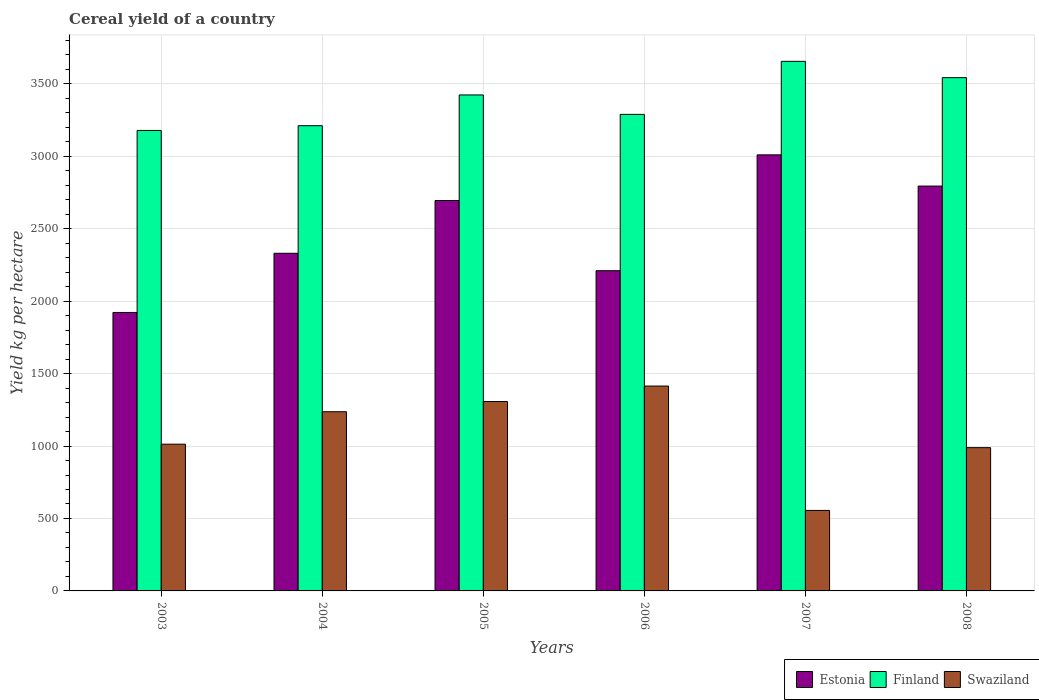Are the number of bars per tick equal to the number of legend labels?
Make the answer very short. Yes. How many bars are there on the 3rd tick from the left?
Make the answer very short. 3. What is the total cereal yield in Estonia in 2008?
Ensure brevity in your answer.  2794.05. Across all years, what is the maximum total cereal yield in Estonia?
Make the answer very short. 3009.47. Across all years, what is the minimum total cereal yield in Finland?
Keep it short and to the point. 3177.97. In which year was the total cereal yield in Swaziland minimum?
Provide a short and direct response. 2007. What is the total total cereal yield in Finland in the graph?
Provide a short and direct response. 2.03e+04. What is the difference between the total cereal yield in Swaziland in 2005 and that in 2007?
Your response must be concise. 751.38. What is the difference between the total cereal yield in Swaziland in 2008 and the total cereal yield in Finland in 2007?
Give a very brief answer. -2665.94. What is the average total cereal yield in Finland per year?
Provide a short and direct response. 3382.86. In the year 2007, what is the difference between the total cereal yield in Estonia and total cereal yield in Swaziland?
Keep it short and to the point. 2453.89. What is the ratio of the total cereal yield in Estonia in 2003 to that in 2005?
Provide a succinct answer. 0.71. What is the difference between the highest and the second highest total cereal yield in Estonia?
Keep it short and to the point. 215.42. What is the difference between the highest and the lowest total cereal yield in Finland?
Keep it short and to the point. 476.74. What does the 3rd bar from the left in 2008 represents?
Offer a terse response. Swaziland. What does the 1st bar from the right in 2005 represents?
Offer a very short reply. Swaziland. How many bars are there?
Ensure brevity in your answer.  18. Are all the bars in the graph horizontal?
Offer a terse response. No. How many years are there in the graph?
Your answer should be very brief. 6. What is the difference between two consecutive major ticks on the Y-axis?
Keep it short and to the point. 500. Are the values on the major ticks of Y-axis written in scientific E-notation?
Provide a succinct answer. No. Does the graph contain grids?
Offer a terse response. Yes. What is the title of the graph?
Provide a short and direct response. Cereal yield of a country. What is the label or title of the X-axis?
Keep it short and to the point. Years. What is the label or title of the Y-axis?
Make the answer very short. Yield kg per hectare. What is the Yield kg per hectare of Estonia in 2003?
Offer a terse response. 1921.7. What is the Yield kg per hectare of Finland in 2003?
Provide a succinct answer. 3177.97. What is the Yield kg per hectare of Swaziland in 2003?
Provide a short and direct response. 1012.66. What is the Yield kg per hectare of Estonia in 2004?
Offer a terse response. 2330.26. What is the Yield kg per hectare in Finland in 2004?
Make the answer very short. 3210.63. What is the Yield kg per hectare in Swaziland in 2004?
Offer a very short reply. 1236.66. What is the Yield kg per hectare in Estonia in 2005?
Provide a succinct answer. 2694.4. What is the Yield kg per hectare of Finland in 2005?
Give a very brief answer. 3422.92. What is the Yield kg per hectare in Swaziland in 2005?
Provide a succinct answer. 1306.95. What is the Yield kg per hectare in Estonia in 2006?
Make the answer very short. 2209.9. What is the Yield kg per hectare of Finland in 2006?
Provide a short and direct response. 3288.7. What is the Yield kg per hectare in Swaziland in 2006?
Your response must be concise. 1413.9. What is the Yield kg per hectare in Estonia in 2007?
Your response must be concise. 3009.47. What is the Yield kg per hectare in Finland in 2007?
Give a very brief answer. 3654.71. What is the Yield kg per hectare of Swaziland in 2007?
Your response must be concise. 555.57. What is the Yield kg per hectare of Estonia in 2008?
Your response must be concise. 2794.05. What is the Yield kg per hectare of Finland in 2008?
Your response must be concise. 3542.26. What is the Yield kg per hectare in Swaziland in 2008?
Offer a terse response. 988.77. Across all years, what is the maximum Yield kg per hectare of Estonia?
Provide a succinct answer. 3009.47. Across all years, what is the maximum Yield kg per hectare in Finland?
Keep it short and to the point. 3654.71. Across all years, what is the maximum Yield kg per hectare of Swaziland?
Offer a very short reply. 1413.9. Across all years, what is the minimum Yield kg per hectare in Estonia?
Provide a short and direct response. 1921.7. Across all years, what is the minimum Yield kg per hectare of Finland?
Offer a very short reply. 3177.97. Across all years, what is the minimum Yield kg per hectare in Swaziland?
Make the answer very short. 555.57. What is the total Yield kg per hectare in Estonia in the graph?
Give a very brief answer. 1.50e+04. What is the total Yield kg per hectare in Finland in the graph?
Your answer should be compact. 2.03e+04. What is the total Yield kg per hectare in Swaziland in the graph?
Provide a succinct answer. 6514.52. What is the difference between the Yield kg per hectare in Estonia in 2003 and that in 2004?
Offer a terse response. -408.56. What is the difference between the Yield kg per hectare of Finland in 2003 and that in 2004?
Ensure brevity in your answer.  -32.66. What is the difference between the Yield kg per hectare in Swaziland in 2003 and that in 2004?
Provide a short and direct response. -224. What is the difference between the Yield kg per hectare of Estonia in 2003 and that in 2005?
Your answer should be compact. -772.7. What is the difference between the Yield kg per hectare of Finland in 2003 and that in 2005?
Provide a short and direct response. -244.95. What is the difference between the Yield kg per hectare of Swaziland in 2003 and that in 2005?
Provide a short and direct response. -294.29. What is the difference between the Yield kg per hectare in Estonia in 2003 and that in 2006?
Provide a short and direct response. -288.2. What is the difference between the Yield kg per hectare of Finland in 2003 and that in 2006?
Offer a very short reply. -110.73. What is the difference between the Yield kg per hectare of Swaziland in 2003 and that in 2006?
Provide a short and direct response. -401.24. What is the difference between the Yield kg per hectare in Estonia in 2003 and that in 2007?
Make the answer very short. -1087.77. What is the difference between the Yield kg per hectare in Finland in 2003 and that in 2007?
Keep it short and to the point. -476.74. What is the difference between the Yield kg per hectare of Swaziland in 2003 and that in 2007?
Give a very brief answer. 457.09. What is the difference between the Yield kg per hectare in Estonia in 2003 and that in 2008?
Ensure brevity in your answer.  -872.35. What is the difference between the Yield kg per hectare of Finland in 2003 and that in 2008?
Provide a succinct answer. -364.29. What is the difference between the Yield kg per hectare in Swaziland in 2003 and that in 2008?
Provide a succinct answer. 23.89. What is the difference between the Yield kg per hectare in Estonia in 2004 and that in 2005?
Your answer should be compact. -364.14. What is the difference between the Yield kg per hectare of Finland in 2004 and that in 2005?
Make the answer very short. -212.29. What is the difference between the Yield kg per hectare in Swaziland in 2004 and that in 2005?
Your answer should be very brief. -70.29. What is the difference between the Yield kg per hectare of Estonia in 2004 and that in 2006?
Your answer should be very brief. 120.35. What is the difference between the Yield kg per hectare of Finland in 2004 and that in 2006?
Your answer should be very brief. -78.07. What is the difference between the Yield kg per hectare of Swaziland in 2004 and that in 2006?
Offer a terse response. -177.24. What is the difference between the Yield kg per hectare in Estonia in 2004 and that in 2007?
Offer a terse response. -679.21. What is the difference between the Yield kg per hectare in Finland in 2004 and that in 2007?
Ensure brevity in your answer.  -444.08. What is the difference between the Yield kg per hectare in Swaziland in 2004 and that in 2007?
Your answer should be compact. 681.09. What is the difference between the Yield kg per hectare of Estonia in 2004 and that in 2008?
Ensure brevity in your answer.  -463.8. What is the difference between the Yield kg per hectare in Finland in 2004 and that in 2008?
Provide a short and direct response. -331.63. What is the difference between the Yield kg per hectare of Swaziland in 2004 and that in 2008?
Provide a short and direct response. 247.89. What is the difference between the Yield kg per hectare of Estonia in 2005 and that in 2006?
Your response must be concise. 484.49. What is the difference between the Yield kg per hectare of Finland in 2005 and that in 2006?
Your response must be concise. 134.22. What is the difference between the Yield kg per hectare in Swaziland in 2005 and that in 2006?
Provide a short and direct response. -106.94. What is the difference between the Yield kg per hectare of Estonia in 2005 and that in 2007?
Ensure brevity in your answer.  -315.07. What is the difference between the Yield kg per hectare of Finland in 2005 and that in 2007?
Provide a succinct answer. -231.78. What is the difference between the Yield kg per hectare in Swaziland in 2005 and that in 2007?
Ensure brevity in your answer.  751.38. What is the difference between the Yield kg per hectare in Estonia in 2005 and that in 2008?
Offer a terse response. -99.66. What is the difference between the Yield kg per hectare in Finland in 2005 and that in 2008?
Keep it short and to the point. -119.33. What is the difference between the Yield kg per hectare of Swaziland in 2005 and that in 2008?
Offer a very short reply. 318.18. What is the difference between the Yield kg per hectare of Estonia in 2006 and that in 2007?
Offer a terse response. -799.57. What is the difference between the Yield kg per hectare of Finland in 2006 and that in 2007?
Provide a succinct answer. -366. What is the difference between the Yield kg per hectare of Swaziland in 2006 and that in 2007?
Your response must be concise. 858.33. What is the difference between the Yield kg per hectare of Estonia in 2006 and that in 2008?
Your answer should be very brief. -584.15. What is the difference between the Yield kg per hectare in Finland in 2006 and that in 2008?
Provide a short and direct response. -253.55. What is the difference between the Yield kg per hectare in Swaziland in 2006 and that in 2008?
Your answer should be compact. 425.13. What is the difference between the Yield kg per hectare in Estonia in 2007 and that in 2008?
Your answer should be compact. 215.42. What is the difference between the Yield kg per hectare in Finland in 2007 and that in 2008?
Ensure brevity in your answer.  112.45. What is the difference between the Yield kg per hectare of Swaziland in 2007 and that in 2008?
Provide a succinct answer. -433.2. What is the difference between the Yield kg per hectare in Estonia in 2003 and the Yield kg per hectare in Finland in 2004?
Ensure brevity in your answer.  -1288.93. What is the difference between the Yield kg per hectare of Estonia in 2003 and the Yield kg per hectare of Swaziland in 2004?
Your answer should be very brief. 685.04. What is the difference between the Yield kg per hectare of Finland in 2003 and the Yield kg per hectare of Swaziland in 2004?
Provide a succinct answer. 1941.31. What is the difference between the Yield kg per hectare of Estonia in 2003 and the Yield kg per hectare of Finland in 2005?
Provide a succinct answer. -1501.22. What is the difference between the Yield kg per hectare in Estonia in 2003 and the Yield kg per hectare in Swaziland in 2005?
Ensure brevity in your answer.  614.75. What is the difference between the Yield kg per hectare of Finland in 2003 and the Yield kg per hectare of Swaziland in 2005?
Ensure brevity in your answer.  1871.02. What is the difference between the Yield kg per hectare in Estonia in 2003 and the Yield kg per hectare in Finland in 2006?
Offer a terse response. -1367. What is the difference between the Yield kg per hectare of Estonia in 2003 and the Yield kg per hectare of Swaziland in 2006?
Your answer should be compact. 507.8. What is the difference between the Yield kg per hectare of Finland in 2003 and the Yield kg per hectare of Swaziland in 2006?
Your answer should be compact. 1764.07. What is the difference between the Yield kg per hectare in Estonia in 2003 and the Yield kg per hectare in Finland in 2007?
Give a very brief answer. -1733.01. What is the difference between the Yield kg per hectare in Estonia in 2003 and the Yield kg per hectare in Swaziland in 2007?
Offer a very short reply. 1366.13. What is the difference between the Yield kg per hectare in Finland in 2003 and the Yield kg per hectare in Swaziland in 2007?
Make the answer very short. 2622.4. What is the difference between the Yield kg per hectare of Estonia in 2003 and the Yield kg per hectare of Finland in 2008?
Keep it short and to the point. -1620.56. What is the difference between the Yield kg per hectare of Estonia in 2003 and the Yield kg per hectare of Swaziland in 2008?
Your answer should be compact. 932.93. What is the difference between the Yield kg per hectare in Finland in 2003 and the Yield kg per hectare in Swaziland in 2008?
Offer a very short reply. 2189.2. What is the difference between the Yield kg per hectare in Estonia in 2004 and the Yield kg per hectare in Finland in 2005?
Give a very brief answer. -1092.66. What is the difference between the Yield kg per hectare of Estonia in 2004 and the Yield kg per hectare of Swaziland in 2005?
Your response must be concise. 1023.3. What is the difference between the Yield kg per hectare in Finland in 2004 and the Yield kg per hectare in Swaziland in 2005?
Your answer should be very brief. 1903.67. What is the difference between the Yield kg per hectare in Estonia in 2004 and the Yield kg per hectare in Finland in 2006?
Your answer should be compact. -958.45. What is the difference between the Yield kg per hectare in Estonia in 2004 and the Yield kg per hectare in Swaziland in 2006?
Your answer should be compact. 916.36. What is the difference between the Yield kg per hectare of Finland in 2004 and the Yield kg per hectare of Swaziland in 2006?
Your answer should be compact. 1796.73. What is the difference between the Yield kg per hectare of Estonia in 2004 and the Yield kg per hectare of Finland in 2007?
Provide a succinct answer. -1324.45. What is the difference between the Yield kg per hectare in Estonia in 2004 and the Yield kg per hectare in Swaziland in 2007?
Your answer should be very brief. 1774.68. What is the difference between the Yield kg per hectare of Finland in 2004 and the Yield kg per hectare of Swaziland in 2007?
Give a very brief answer. 2655.05. What is the difference between the Yield kg per hectare of Estonia in 2004 and the Yield kg per hectare of Finland in 2008?
Give a very brief answer. -1212. What is the difference between the Yield kg per hectare in Estonia in 2004 and the Yield kg per hectare in Swaziland in 2008?
Offer a terse response. 1341.49. What is the difference between the Yield kg per hectare of Finland in 2004 and the Yield kg per hectare of Swaziland in 2008?
Provide a short and direct response. 2221.86. What is the difference between the Yield kg per hectare in Estonia in 2005 and the Yield kg per hectare in Finland in 2006?
Provide a succinct answer. -594.31. What is the difference between the Yield kg per hectare of Estonia in 2005 and the Yield kg per hectare of Swaziland in 2006?
Provide a succinct answer. 1280.5. What is the difference between the Yield kg per hectare in Finland in 2005 and the Yield kg per hectare in Swaziland in 2006?
Your answer should be very brief. 2009.02. What is the difference between the Yield kg per hectare in Estonia in 2005 and the Yield kg per hectare in Finland in 2007?
Your answer should be compact. -960.31. What is the difference between the Yield kg per hectare of Estonia in 2005 and the Yield kg per hectare of Swaziland in 2007?
Your answer should be very brief. 2138.82. What is the difference between the Yield kg per hectare of Finland in 2005 and the Yield kg per hectare of Swaziland in 2007?
Make the answer very short. 2867.35. What is the difference between the Yield kg per hectare of Estonia in 2005 and the Yield kg per hectare of Finland in 2008?
Provide a succinct answer. -847.86. What is the difference between the Yield kg per hectare of Estonia in 2005 and the Yield kg per hectare of Swaziland in 2008?
Offer a very short reply. 1705.63. What is the difference between the Yield kg per hectare in Finland in 2005 and the Yield kg per hectare in Swaziland in 2008?
Your answer should be very brief. 2434.15. What is the difference between the Yield kg per hectare of Estonia in 2006 and the Yield kg per hectare of Finland in 2007?
Offer a terse response. -1444.8. What is the difference between the Yield kg per hectare in Estonia in 2006 and the Yield kg per hectare in Swaziland in 2007?
Offer a terse response. 1654.33. What is the difference between the Yield kg per hectare of Finland in 2006 and the Yield kg per hectare of Swaziland in 2007?
Provide a succinct answer. 2733.13. What is the difference between the Yield kg per hectare in Estonia in 2006 and the Yield kg per hectare in Finland in 2008?
Offer a very short reply. -1332.35. What is the difference between the Yield kg per hectare in Estonia in 2006 and the Yield kg per hectare in Swaziland in 2008?
Provide a short and direct response. 1221.13. What is the difference between the Yield kg per hectare of Finland in 2006 and the Yield kg per hectare of Swaziland in 2008?
Ensure brevity in your answer.  2299.93. What is the difference between the Yield kg per hectare in Estonia in 2007 and the Yield kg per hectare in Finland in 2008?
Ensure brevity in your answer.  -532.79. What is the difference between the Yield kg per hectare in Estonia in 2007 and the Yield kg per hectare in Swaziland in 2008?
Your answer should be compact. 2020.7. What is the difference between the Yield kg per hectare of Finland in 2007 and the Yield kg per hectare of Swaziland in 2008?
Provide a succinct answer. 2665.94. What is the average Yield kg per hectare of Estonia per year?
Your answer should be compact. 2493.3. What is the average Yield kg per hectare in Finland per year?
Offer a terse response. 3382.86. What is the average Yield kg per hectare in Swaziland per year?
Your response must be concise. 1085.75. In the year 2003, what is the difference between the Yield kg per hectare of Estonia and Yield kg per hectare of Finland?
Ensure brevity in your answer.  -1256.27. In the year 2003, what is the difference between the Yield kg per hectare of Estonia and Yield kg per hectare of Swaziland?
Keep it short and to the point. 909.04. In the year 2003, what is the difference between the Yield kg per hectare in Finland and Yield kg per hectare in Swaziland?
Your answer should be compact. 2165.31. In the year 2004, what is the difference between the Yield kg per hectare in Estonia and Yield kg per hectare in Finland?
Make the answer very short. -880.37. In the year 2004, what is the difference between the Yield kg per hectare of Estonia and Yield kg per hectare of Swaziland?
Give a very brief answer. 1093.6. In the year 2004, what is the difference between the Yield kg per hectare in Finland and Yield kg per hectare in Swaziland?
Offer a terse response. 1973.97. In the year 2005, what is the difference between the Yield kg per hectare in Estonia and Yield kg per hectare in Finland?
Offer a very short reply. -728.52. In the year 2005, what is the difference between the Yield kg per hectare of Estonia and Yield kg per hectare of Swaziland?
Your answer should be very brief. 1387.44. In the year 2005, what is the difference between the Yield kg per hectare of Finland and Yield kg per hectare of Swaziland?
Your response must be concise. 2115.97. In the year 2006, what is the difference between the Yield kg per hectare of Estonia and Yield kg per hectare of Finland?
Make the answer very short. -1078.8. In the year 2006, what is the difference between the Yield kg per hectare in Estonia and Yield kg per hectare in Swaziland?
Provide a short and direct response. 796. In the year 2006, what is the difference between the Yield kg per hectare in Finland and Yield kg per hectare in Swaziland?
Your response must be concise. 1874.8. In the year 2007, what is the difference between the Yield kg per hectare in Estonia and Yield kg per hectare in Finland?
Keep it short and to the point. -645.24. In the year 2007, what is the difference between the Yield kg per hectare of Estonia and Yield kg per hectare of Swaziland?
Offer a very short reply. 2453.89. In the year 2007, what is the difference between the Yield kg per hectare in Finland and Yield kg per hectare in Swaziland?
Ensure brevity in your answer.  3099.13. In the year 2008, what is the difference between the Yield kg per hectare of Estonia and Yield kg per hectare of Finland?
Provide a succinct answer. -748.21. In the year 2008, what is the difference between the Yield kg per hectare of Estonia and Yield kg per hectare of Swaziland?
Keep it short and to the point. 1805.28. In the year 2008, what is the difference between the Yield kg per hectare of Finland and Yield kg per hectare of Swaziland?
Ensure brevity in your answer.  2553.49. What is the ratio of the Yield kg per hectare in Estonia in 2003 to that in 2004?
Your response must be concise. 0.82. What is the ratio of the Yield kg per hectare of Finland in 2003 to that in 2004?
Provide a succinct answer. 0.99. What is the ratio of the Yield kg per hectare of Swaziland in 2003 to that in 2004?
Your answer should be compact. 0.82. What is the ratio of the Yield kg per hectare in Estonia in 2003 to that in 2005?
Your answer should be compact. 0.71. What is the ratio of the Yield kg per hectare of Finland in 2003 to that in 2005?
Your answer should be very brief. 0.93. What is the ratio of the Yield kg per hectare of Swaziland in 2003 to that in 2005?
Ensure brevity in your answer.  0.77. What is the ratio of the Yield kg per hectare in Estonia in 2003 to that in 2006?
Offer a terse response. 0.87. What is the ratio of the Yield kg per hectare of Finland in 2003 to that in 2006?
Keep it short and to the point. 0.97. What is the ratio of the Yield kg per hectare in Swaziland in 2003 to that in 2006?
Offer a very short reply. 0.72. What is the ratio of the Yield kg per hectare of Estonia in 2003 to that in 2007?
Your answer should be compact. 0.64. What is the ratio of the Yield kg per hectare in Finland in 2003 to that in 2007?
Your answer should be compact. 0.87. What is the ratio of the Yield kg per hectare in Swaziland in 2003 to that in 2007?
Your answer should be compact. 1.82. What is the ratio of the Yield kg per hectare in Estonia in 2003 to that in 2008?
Provide a short and direct response. 0.69. What is the ratio of the Yield kg per hectare of Finland in 2003 to that in 2008?
Your answer should be very brief. 0.9. What is the ratio of the Yield kg per hectare in Swaziland in 2003 to that in 2008?
Keep it short and to the point. 1.02. What is the ratio of the Yield kg per hectare in Estonia in 2004 to that in 2005?
Keep it short and to the point. 0.86. What is the ratio of the Yield kg per hectare of Finland in 2004 to that in 2005?
Offer a terse response. 0.94. What is the ratio of the Yield kg per hectare of Swaziland in 2004 to that in 2005?
Make the answer very short. 0.95. What is the ratio of the Yield kg per hectare of Estonia in 2004 to that in 2006?
Provide a succinct answer. 1.05. What is the ratio of the Yield kg per hectare in Finland in 2004 to that in 2006?
Offer a terse response. 0.98. What is the ratio of the Yield kg per hectare of Swaziland in 2004 to that in 2006?
Ensure brevity in your answer.  0.87. What is the ratio of the Yield kg per hectare of Estonia in 2004 to that in 2007?
Provide a short and direct response. 0.77. What is the ratio of the Yield kg per hectare in Finland in 2004 to that in 2007?
Keep it short and to the point. 0.88. What is the ratio of the Yield kg per hectare of Swaziland in 2004 to that in 2007?
Provide a succinct answer. 2.23. What is the ratio of the Yield kg per hectare of Estonia in 2004 to that in 2008?
Provide a succinct answer. 0.83. What is the ratio of the Yield kg per hectare in Finland in 2004 to that in 2008?
Make the answer very short. 0.91. What is the ratio of the Yield kg per hectare of Swaziland in 2004 to that in 2008?
Your answer should be compact. 1.25. What is the ratio of the Yield kg per hectare in Estonia in 2005 to that in 2006?
Your answer should be compact. 1.22. What is the ratio of the Yield kg per hectare of Finland in 2005 to that in 2006?
Your response must be concise. 1.04. What is the ratio of the Yield kg per hectare in Swaziland in 2005 to that in 2006?
Provide a short and direct response. 0.92. What is the ratio of the Yield kg per hectare of Estonia in 2005 to that in 2007?
Provide a succinct answer. 0.9. What is the ratio of the Yield kg per hectare in Finland in 2005 to that in 2007?
Your answer should be very brief. 0.94. What is the ratio of the Yield kg per hectare in Swaziland in 2005 to that in 2007?
Keep it short and to the point. 2.35. What is the ratio of the Yield kg per hectare in Estonia in 2005 to that in 2008?
Provide a short and direct response. 0.96. What is the ratio of the Yield kg per hectare in Finland in 2005 to that in 2008?
Your answer should be very brief. 0.97. What is the ratio of the Yield kg per hectare of Swaziland in 2005 to that in 2008?
Keep it short and to the point. 1.32. What is the ratio of the Yield kg per hectare of Estonia in 2006 to that in 2007?
Your response must be concise. 0.73. What is the ratio of the Yield kg per hectare of Finland in 2006 to that in 2007?
Ensure brevity in your answer.  0.9. What is the ratio of the Yield kg per hectare of Swaziland in 2006 to that in 2007?
Provide a succinct answer. 2.54. What is the ratio of the Yield kg per hectare of Estonia in 2006 to that in 2008?
Make the answer very short. 0.79. What is the ratio of the Yield kg per hectare of Finland in 2006 to that in 2008?
Your response must be concise. 0.93. What is the ratio of the Yield kg per hectare in Swaziland in 2006 to that in 2008?
Keep it short and to the point. 1.43. What is the ratio of the Yield kg per hectare of Estonia in 2007 to that in 2008?
Offer a very short reply. 1.08. What is the ratio of the Yield kg per hectare in Finland in 2007 to that in 2008?
Provide a succinct answer. 1.03. What is the ratio of the Yield kg per hectare in Swaziland in 2007 to that in 2008?
Offer a very short reply. 0.56. What is the difference between the highest and the second highest Yield kg per hectare in Estonia?
Your answer should be very brief. 215.42. What is the difference between the highest and the second highest Yield kg per hectare of Finland?
Offer a terse response. 112.45. What is the difference between the highest and the second highest Yield kg per hectare in Swaziland?
Provide a succinct answer. 106.94. What is the difference between the highest and the lowest Yield kg per hectare of Estonia?
Keep it short and to the point. 1087.77. What is the difference between the highest and the lowest Yield kg per hectare in Finland?
Provide a succinct answer. 476.74. What is the difference between the highest and the lowest Yield kg per hectare in Swaziland?
Your answer should be compact. 858.33. 